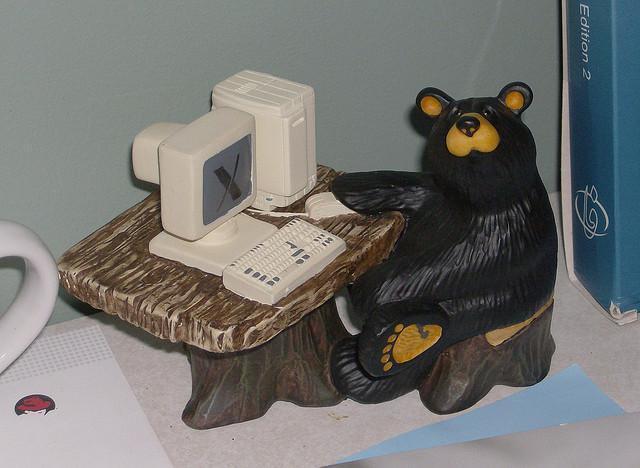How many bears are here?
Give a very brief answer. 1. How many teddy bears are visible?
Give a very brief answer. 1. How many orange slices can you see?
Give a very brief answer. 0. 